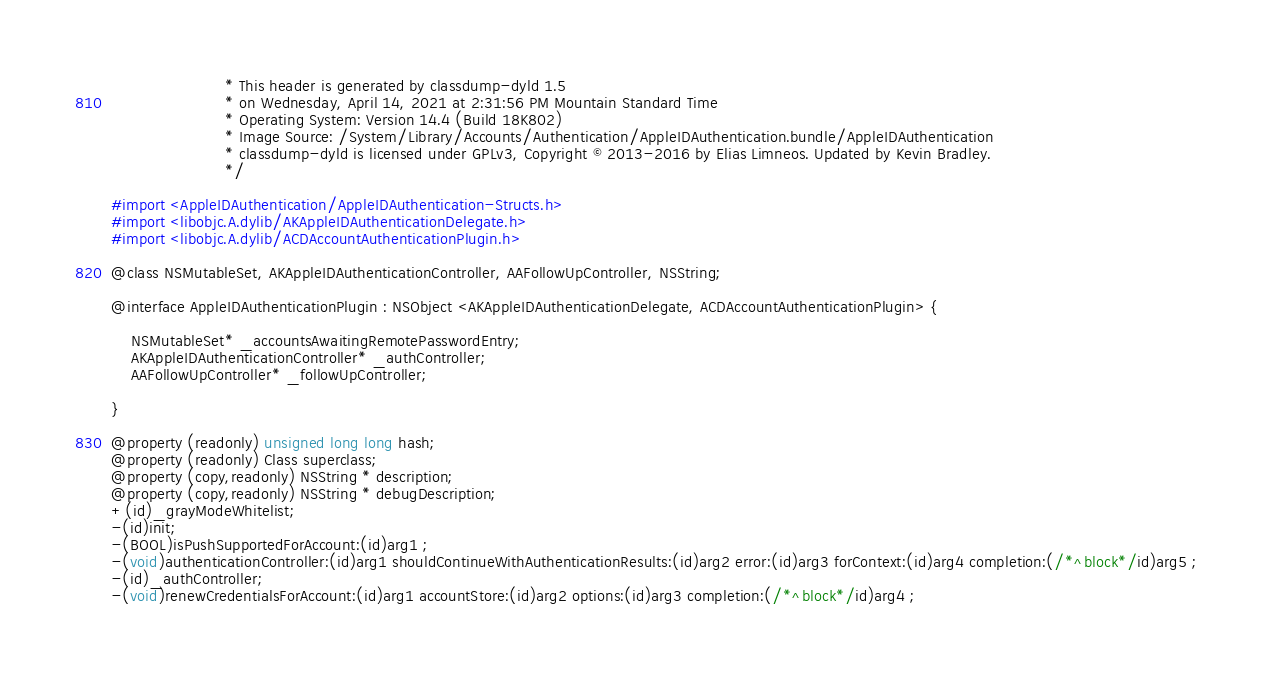<code> <loc_0><loc_0><loc_500><loc_500><_C_>                       * This header is generated by classdump-dyld 1.5
                       * on Wednesday, April 14, 2021 at 2:31:56 PM Mountain Standard Time
                       * Operating System: Version 14.4 (Build 18K802)
                       * Image Source: /System/Library/Accounts/Authentication/AppleIDAuthentication.bundle/AppleIDAuthentication
                       * classdump-dyld is licensed under GPLv3, Copyright © 2013-2016 by Elias Limneos. Updated by Kevin Bradley.
                       */

#import <AppleIDAuthentication/AppleIDAuthentication-Structs.h>
#import <libobjc.A.dylib/AKAppleIDAuthenticationDelegate.h>
#import <libobjc.A.dylib/ACDAccountAuthenticationPlugin.h>

@class NSMutableSet, AKAppleIDAuthenticationController, AAFollowUpController, NSString;

@interface AppleIDAuthenticationPlugin : NSObject <AKAppleIDAuthenticationDelegate, ACDAccountAuthenticationPlugin> {

	NSMutableSet* _accountsAwaitingRemotePasswordEntry;
	AKAppleIDAuthenticationController* _authController;
	AAFollowUpController* _followUpController;

}

@property (readonly) unsigned long long hash; 
@property (readonly) Class superclass; 
@property (copy,readonly) NSString * description; 
@property (copy,readonly) NSString * debugDescription; 
+(id)_grayModeWhitelist;
-(id)init;
-(BOOL)isPushSupportedForAccount:(id)arg1 ;
-(void)authenticationController:(id)arg1 shouldContinueWithAuthenticationResults:(id)arg2 error:(id)arg3 forContext:(id)arg4 completion:(/*^block*/id)arg5 ;
-(id)_authController;
-(void)renewCredentialsForAccount:(id)arg1 accountStore:(id)arg2 options:(id)arg3 completion:(/*^block*/id)arg4 ;</code> 